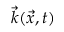<formula> <loc_0><loc_0><loc_500><loc_500>\vec { k } ( \vec { x } , t )</formula> 